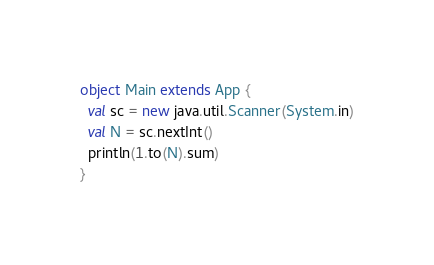Convert code to text. <code><loc_0><loc_0><loc_500><loc_500><_Scala_>object Main extends App {
  val sc = new java.util.Scanner(System.in)
  val N = sc.nextInt()
  println(1.to(N).sum)
}
</code> 